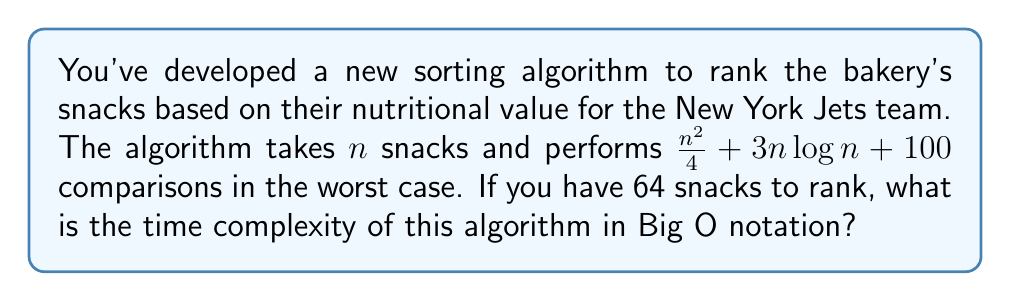Give your solution to this math problem. To determine the time complexity in Big O notation, we need to identify the dominant term in the given expression as $n$ grows large. Let's analyze each term:

1. $\frac{n^2}{4}$: This is a quadratic term.
2. $3n\log n$: This is a linearithmic term.
3. $100$: This is a constant term.

For $n = 64$, we can calculate:

1. $\frac{n^2}{4} = \frac{64^2}{4} = 1024$
2. $3n\log n = 3 \cdot 64 \cdot \log_2 64 = 3 \cdot 64 \cdot 6 = 1152$
3. $100$ (constant)

As $n$ grows larger, the quadratic term $\frac{n^2}{4}$ will dominate the others. We can ignore constant factors in Big O notation, so $\frac{n^2}{4}$ simplifies to $O(n^2)$.

The $3n\log n$ term grows more slowly than $n^2$, and the constant 100 becomes negligible for large $n$.

Therefore, the overall time complexity of the algorithm is $O(n^2)$.
Answer: $O(n^2)$ 